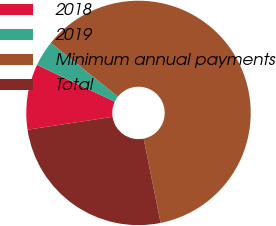<chart> <loc_0><loc_0><loc_500><loc_500><pie_chart><fcel>2018<fcel>2019<fcel>Minimum annual payments<fcel>Total<nl><fcel>9.43%<fcel>3.68%<fcel>61.12%<fcel>25.77%<nl></chart> 